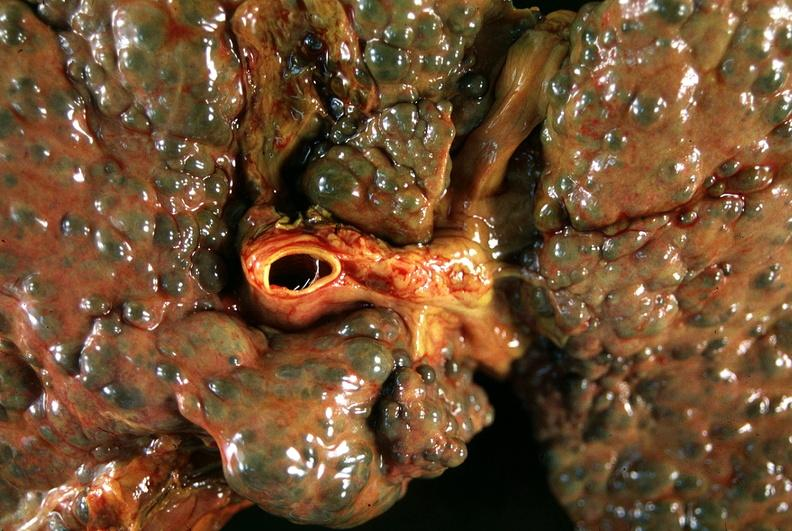what does this image show?
Answer the question using a single word or phrase. Liver 